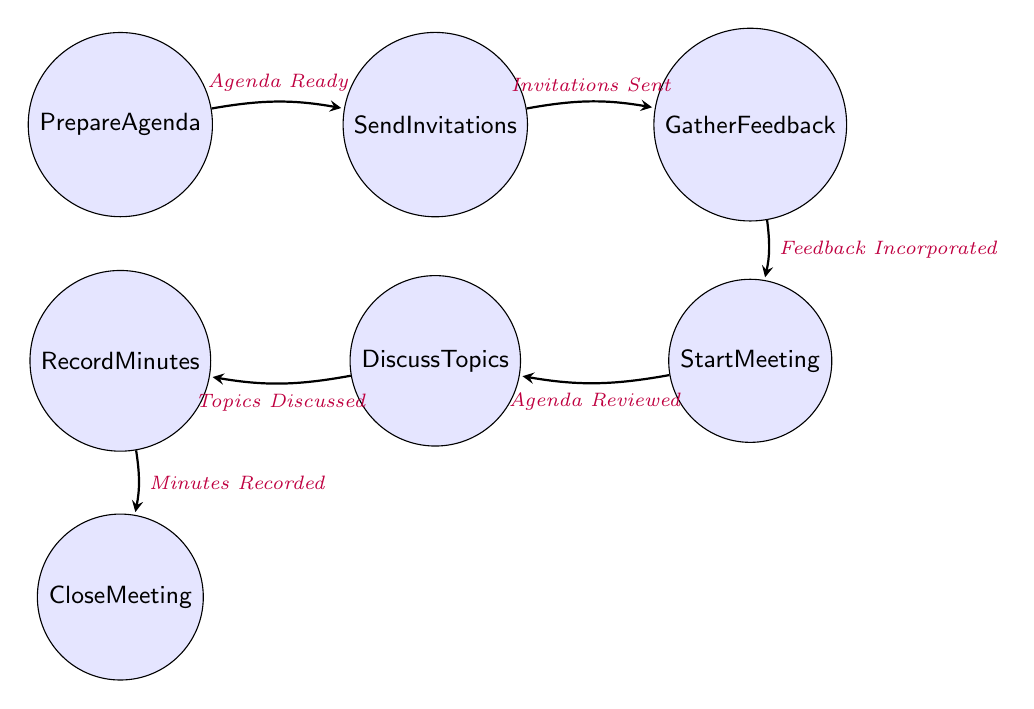What is the first state in the process? The diagram starts at the node labeled "Prepare Agenda," which is the first step in organizing the faculty meeting.
Answer: Prepare Agenda How many states are there in total? The diagram lists a total of seven states related to the faculty meeting process, from preparing the agenda to closing the meeting.
Answer: Seven What condition leads from "Send Invitations" to "Gather Feedback"? The transition between these two states occurs when the invitations are sent out, which is indicated by the condition "Invitations Sent."
Answer: Invitations Sent What is the last state in the process? The final step in the process as shown in the diagram is "Close Meeting," which marks the end of the faculty meeting organization.
Answer: Close Meeting Which state follows "Start Meeting"? Following "Start Meeting," the next state in the process is "Discuss Topics," where the actual discussions occur.
Answer: Discuss Topics What is the condition for moving to "Record Minutes"? The transition from "Discuss Topics" to "Record Minutes" is triggered when all the topics have been discussed, labeled as "Topics Discussed."
Answer: Topics Discussed What is the direct relationship between "Gather Feedback" and "Start Meeting"? The transition between these two nodes indicates that the meeting can only start after feedback has been incorporated, as conveyed by the condition "Feedback Incorporated."
Answer: Feedback Incorporated How does one move from "Prepare Agenda" to "Send Invitations"? The move from "Prepare Agenda" to "Send Invitations" occurs when the agenda is ready, which is marked by the condition "Agenda Ready."
Answer: Agenda Ready What state must be completed before "Close Meeting"? Before reaching the "Close Meeting" state, the "Record Minutes" state must be completed, which records the key points of the meeting.
Answer: Record Minutes 